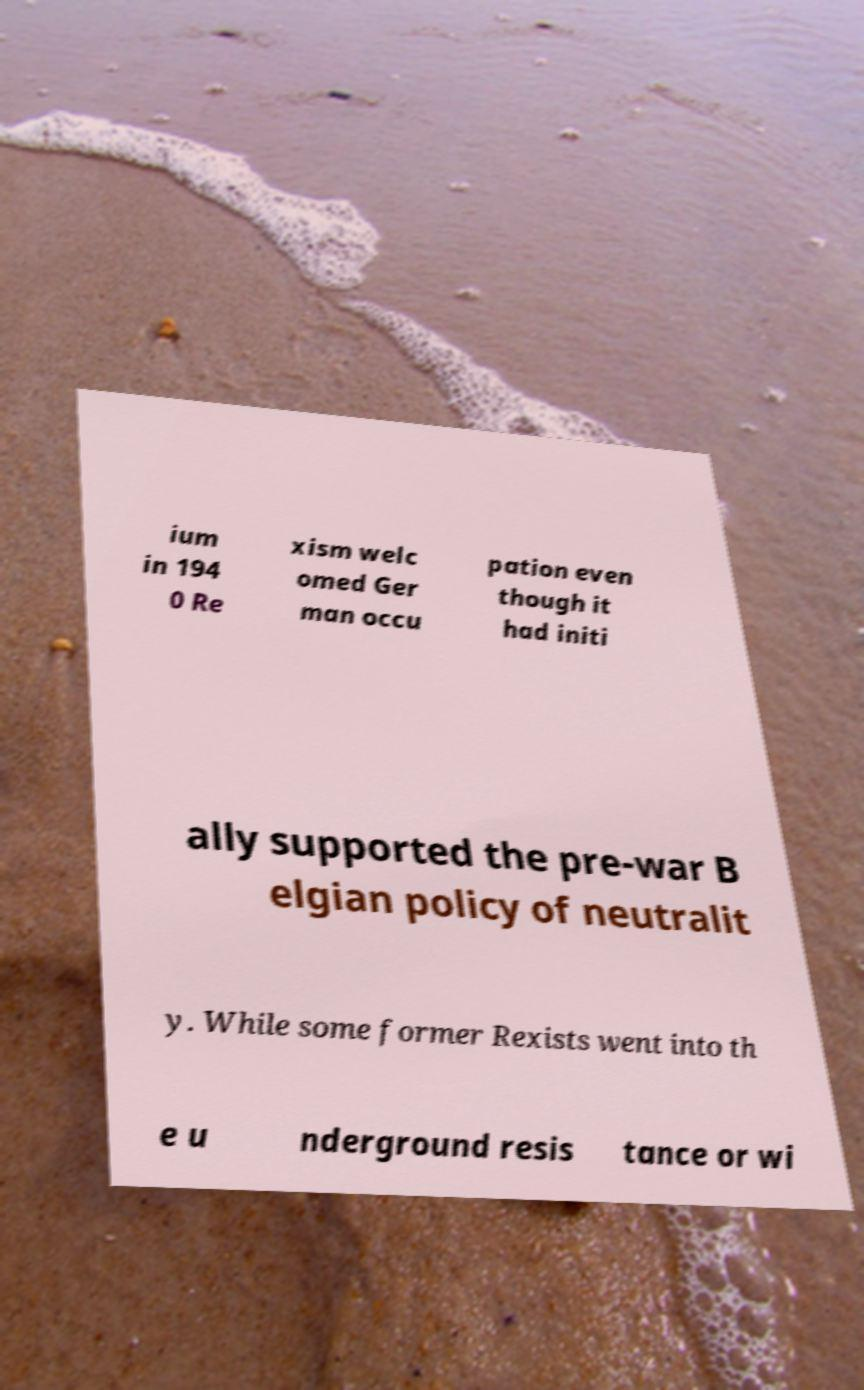Could you extract and type out the text from this image? ium in 194 0 Re xism welc omed Ger man occu pation even though it had initi ally supported the pre-war B elgian policy of neutralit y. While some former Rexists went into th e u nderground resis tance or wi 